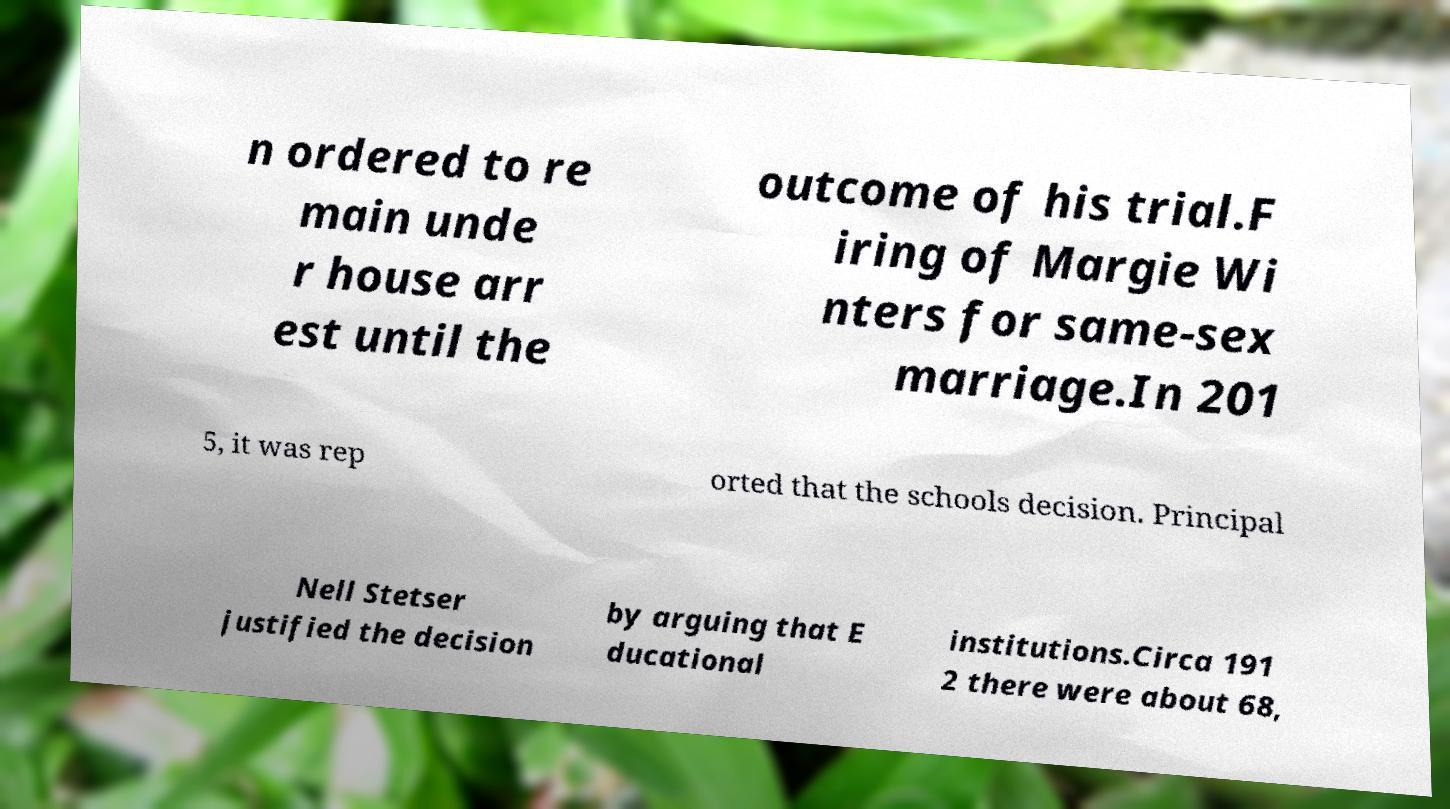Please identify and transcribe the text found in this image. n ordered to re main unde r house arr est until the outcome of his trial.F iring of Margie Wi nters for same-sex marriage.In 201 5, it was rep orted that the schools decision. Principal Nell Stetser justified the decision by arguing that E ducational institutions.Circa 191 2 there were about 68, 